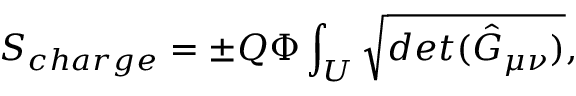Convert formula to latex. <formula><loc_0><loc_0><loc_500><loc_500>S _ { c h \arg e } = { \pm } Q { \Phi } \int _ { U } \sqrt { d e t ( { \hat { G } } _ { \mu \nu } ) } ,</formula> 